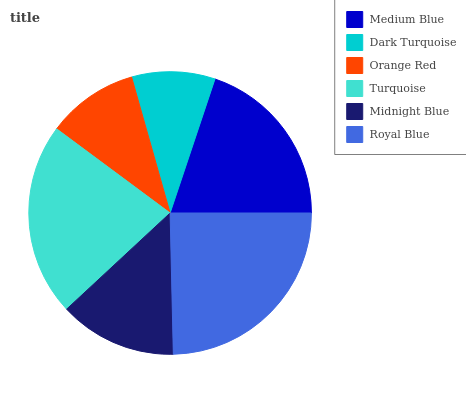Is Dark Turquoise the minimum?
Answer yes or no. Yes. Is Royal Blue the maximum?
Answer yes or no. Yes. Is Orange Red the minimum?
Answer yes or no. No. Is Orange Red the maximum?
Answer yes or no. No. Is Orange Red greater than Dark Turquoise?
Answer yes or no. Yes. Is Dark Turquoise less than Orange Red?
Answer yes or no. Yes. Is Dark Turquoise greater than Orange Red?
Answer yes or no. No. Is Orange Red less than Dark Turquoise?
Answer yes or no. No. Is Medium Blue the high median?
Answer yes or no. Yes. Is Midnight Blue the low median?
Answer yes or no. Yes. Is Dark Turquoise the high median?
Answer yes or no. No. Is Orange Red the low median?
Answer yes or no. No. 